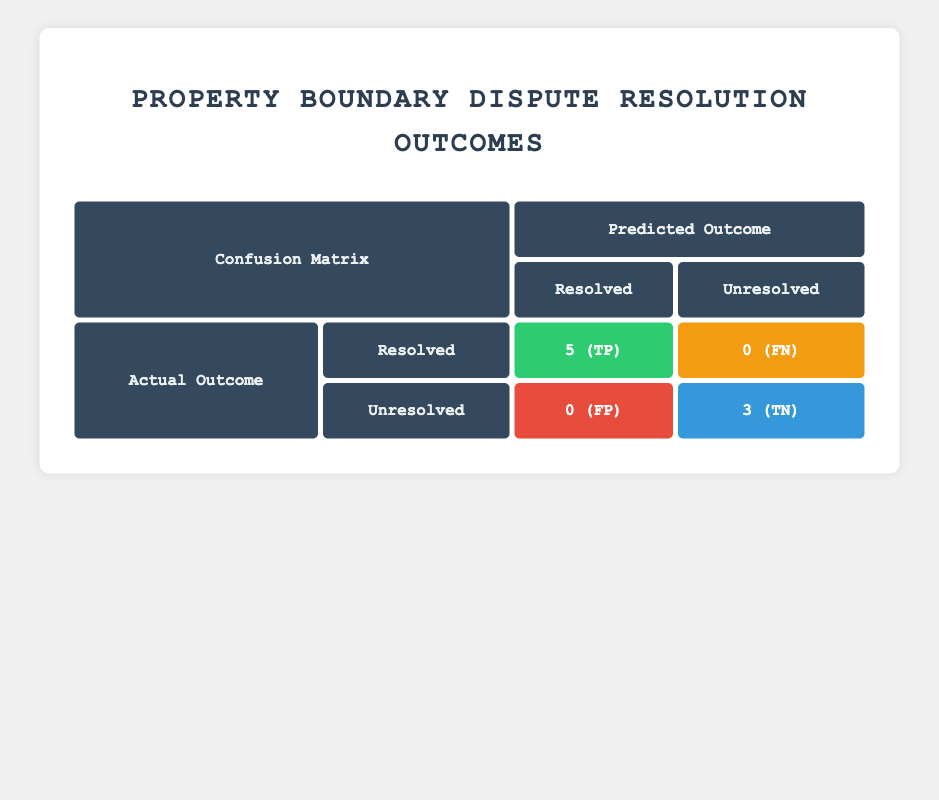What is the total number of disputes classified as "Resolved"? From the table, we see that the "Resolved" status has values in the "Actual Outcome" row for "Resolved," which are counted as 5 (TP) in that cell. Therefore, there are a total of 5 disputes classified as "Resolved."
Answer: 5 How many disputes were classified as "Unresolved"? The "Unresolved" row in the "Actual Outcome" section shows the count of "Unresolved" disputes, which is 3 (TN) in the relevant cell. Hence, the total number of class disputes classified as "Unresolved" is 3.
Answer: 3 What is the number of disputes where the initial resolution was "Litigation"? To find this, we can refer to the incidents where the initial resolution method listed was "Litigation." From the data, there are 2 disputes where "Litigation" was the initial resolution (disputes 5 and 7). Therefore, the total is 2.
Answer: 2 Is there a case where a dispute was resolved through "Mediation"? Checking the table, we see that there are entries in the "Resolved" column, and indeed, disputes 4 and 8 had "Mediation" as the initial resolution and ended up resolved. Therefore, the answer is yes.
Answer: Yes What percentage of disputes ended with a "Failure" status? From the table, there are 2 disputes classified as failures (disputes 2, 5, and 6) out of a total of 8 disputes. To determine the percentage, we calculate (3/8) * 100 = 37.5%.
Answer: 37.5% How many initial resolution methods ended with a success outcome? We can determine this by checking which initial resolution methods resulted in "Resolved." The successes include "Survey" for disputes 1, 3, and "Mediation" for dispute 4 and "Litigation" for dispute 7, totaling 5 successful initial resolutions.
Answer: 5 What is the difference in the count of "True Positives" and "False Negatives"? The table indicates 5 true positives (TP) and 0 false negatives (FN). To find the difference, we calculate 5 - 0 = 5. Thus, the difference is 5.
Answer: 5 How many disputes were resolved but started with "Survey" as the initial resolution? Looking at the table, we identify that both disputes 1 and 3 had an initial resolution of "Survey" and concluded as "Resolved." Therefore, the count of such disputes is 2.
Answer: 2 Were there more failures than successes in the actual outcomes? In the confusion matrix, we see that there are 5 successful outcomes and 3 failures. Since 5 is more than 3, the answer is no; there were not more failures than successes.
Answer: No 